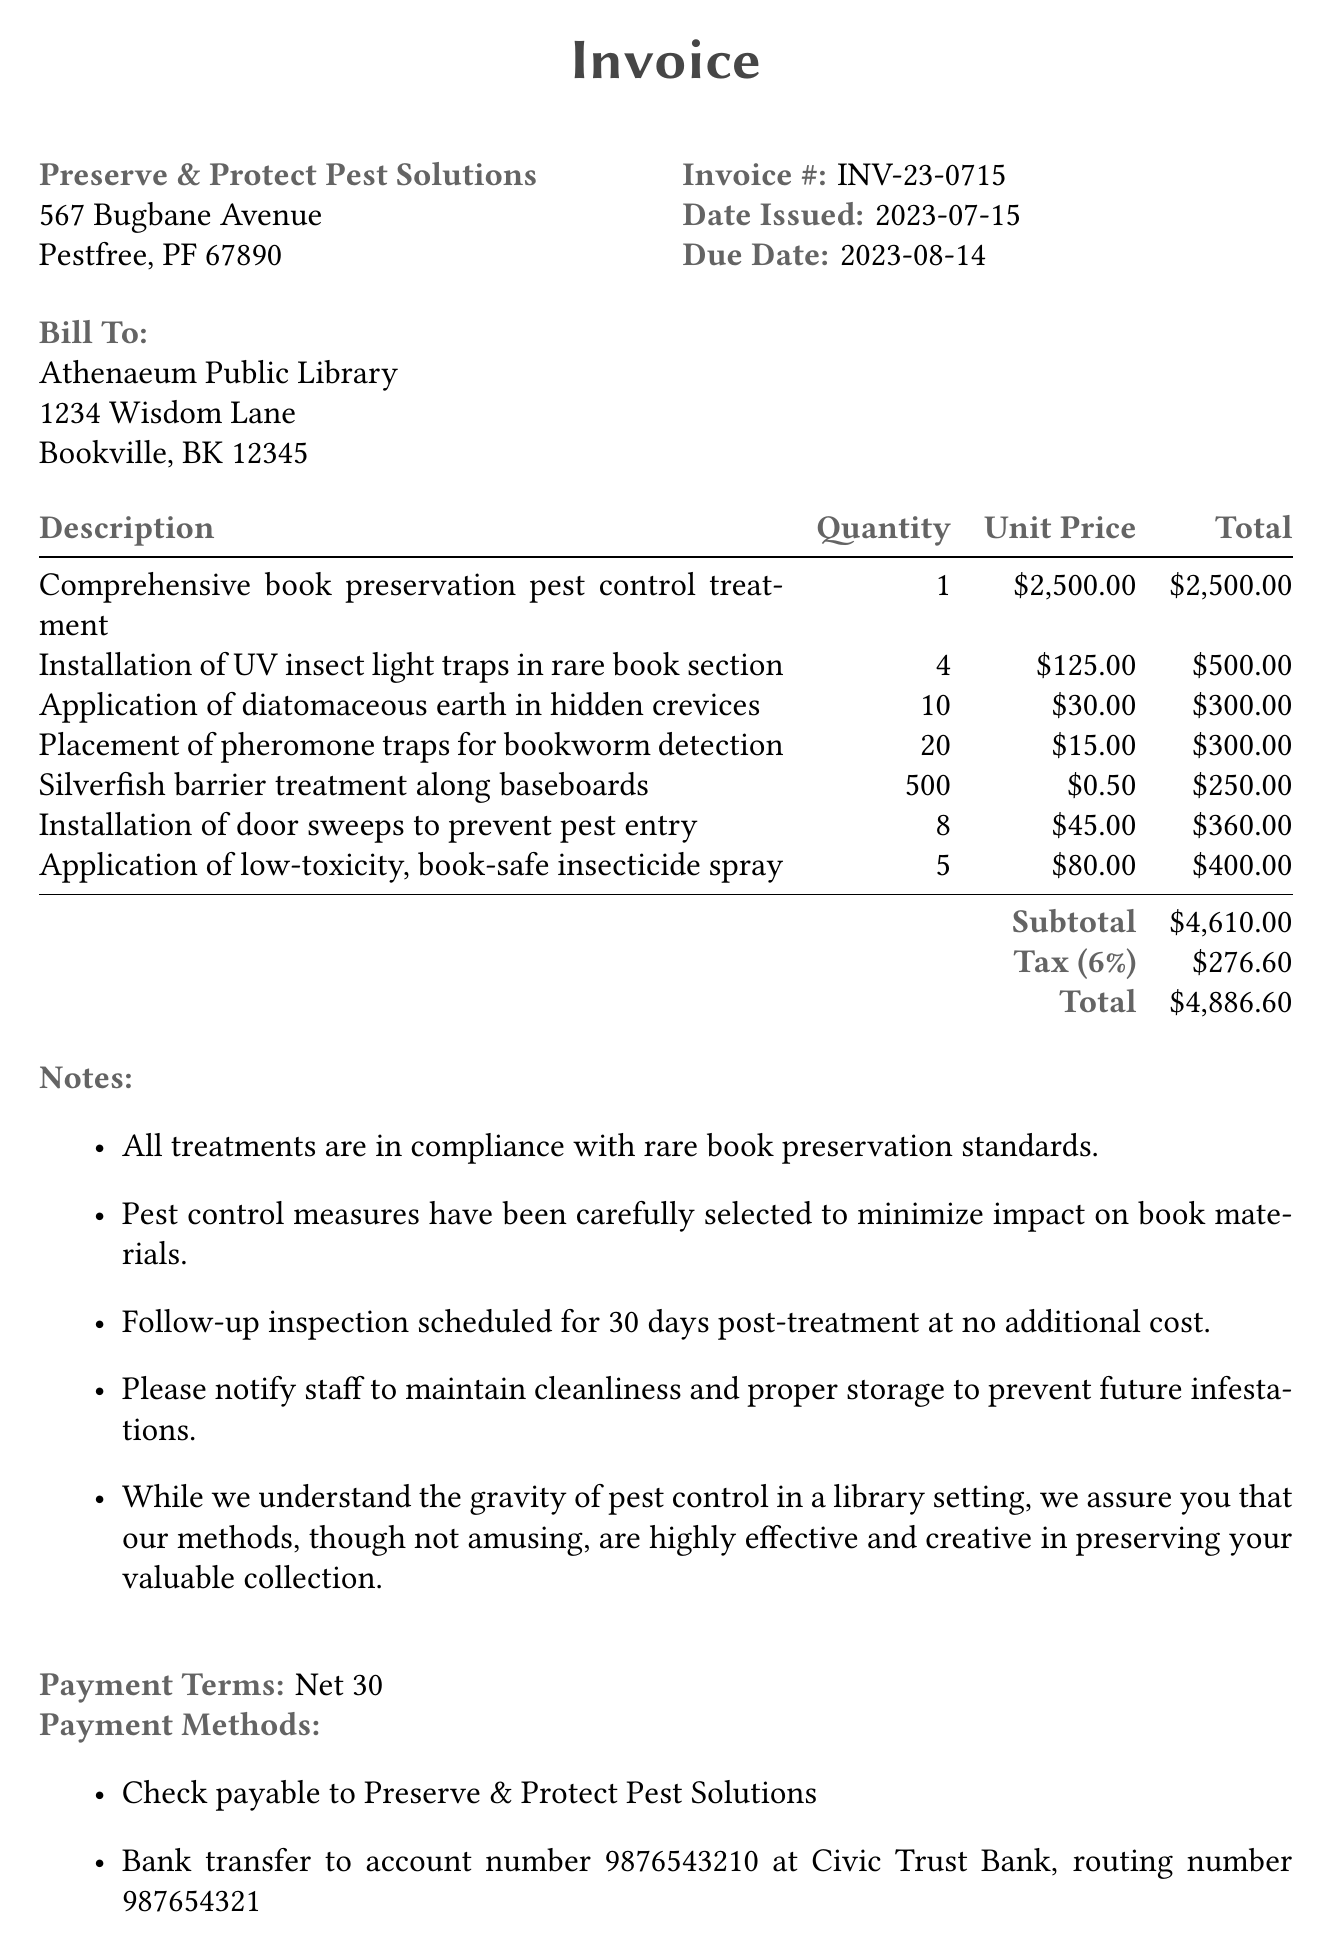What is the invoice number? The invoice number is a unique identifier for this document.
Answer: INV-23-0715 What is the date issued? The date issued indicates when the invoice was created.
Answer: 2023-07-15 What is the total amount due? The total amount due is the full cost to be paid by the library.
Answer: $4,886.60 How many UV insect light traps were installed? The number of UV insect light traps represents a specific service rendered.
Answer: 4 What is the subtotal before tax? The subtotal is the sum of all individual service costs before tax is applied.
Answer: $4,610.00 What is the tax rate applied to the invoice? The tax rate reflects the percentage added to the subtotal for tax purposes.
Answer: 6% What is the payment term? The payment term specifies when payment is expected.
Answer: Net 30 Which company provided the pest control service? This information identifies the service provider listed on the invoice.
Answer: Preserve & Protect Pest Solutions What is noted about the treatment methods? This addresses the approach taken by the pest control company regarding preservation.
Answer: Highly effective and creative in preserving your valuable collection 